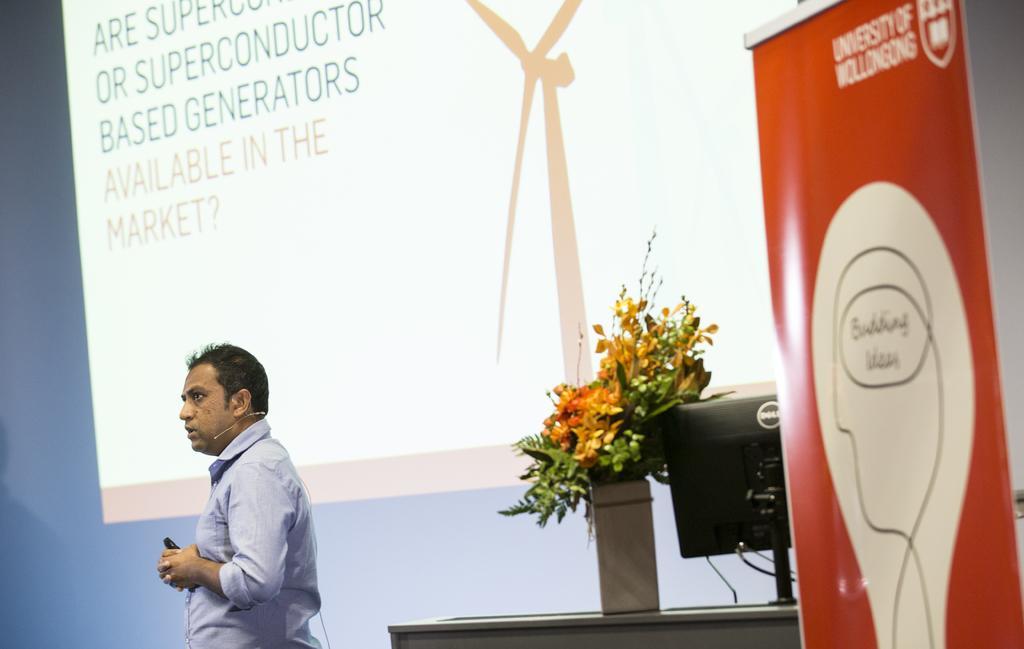Please provide a concise description of this image. In the image there is man in blue shirt standing in front of the screen, on the right side there is a table with computer and flower vase on it in front of a banner. 